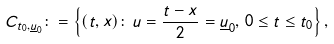<formula> <loc_0><loc_0><loc_500><loc_500>C _ { t _ { 0 } , \underline { u } _ { 0 } } \colon = \left \{ ( t , x ) \colon \, u = \frac { t - x } { 2 } = \underline { u } _ { 0 } , \, 0 \leq t \leq t _ { 0 } \right \} ,</formula> 